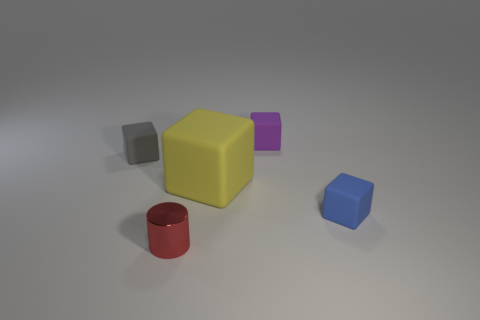What is the shape of the tiny thing behind the small rubber cube left of the big yellow thing?
Offer a terse response. Cube. Are there any other things that are the same size as the yellow matte object?
Make the answer very short. No. Is there anything else that has the same shape as the red metal thing?
Your answer should be very brief. No. What number of other things are made of the same material as the small purple block?
Your response must be concise. 3. How many red objects are the same size as the yellow matte object?
Offer a terse response. 0. What number of yellow objects are either matte blocks or tiny rubber cylinders?
Ensure brevity in your answer.  1. Is the number of blue rubber cubes that are left of the gray rubber cube the same as the number of small gray cubes?
Provide a succinct answer. No. What is the size of the rubber block that is to the left of the big matte cube?
Offer a terse response. Small. What number of small purple rubber objects have the same shape as the tiny gray object?
Offer a terse response. 1. There is a small thing that is behind the large cube and to the left of the yellow rubber block; what is it made of?
Provide a succinct answer. Rubber. 